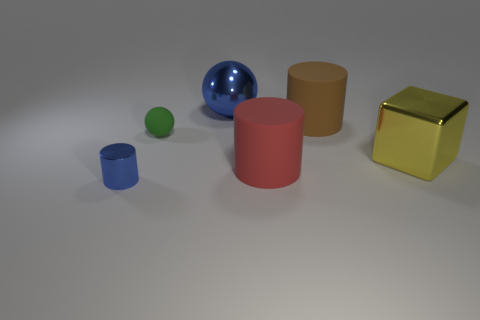Subtract all matte cylinders. How many cylinders are left? 1 Add 4 big cylinders. How many objects exist? 10 Subtract 1 spheres. How many spheres are left? 1 Subtract all balls. How many objects are left? 4 Subtract all blue spheres. Subtract all cyan blocks. How many spheres are left? 1 Subtract all green balls. Subtract all large rubber objects. How many objects are left? 3 Add 2 big red cylinders. How many big red cylinders are left? 3 Add 1 tiny yellow cubes. How many tiny yellow cubes exist? 1 Subtract 0 gray spheres. How many objects are left? 6 